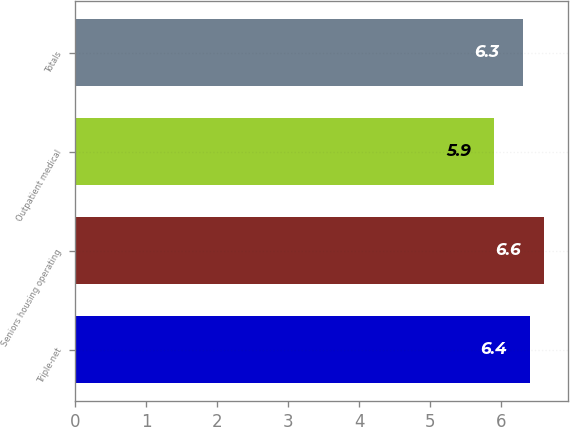<chart> <loc_0><loc_0><loc_500><loc_500><bar_chart><fcel>Triple-net<fcel>Seniors housing operating<fcel>Outpatient medical<fcel>Totals<nl><fcel>6.4<fcel>6.6<fcel>5.9<fcel>6.3<nl></chart> 